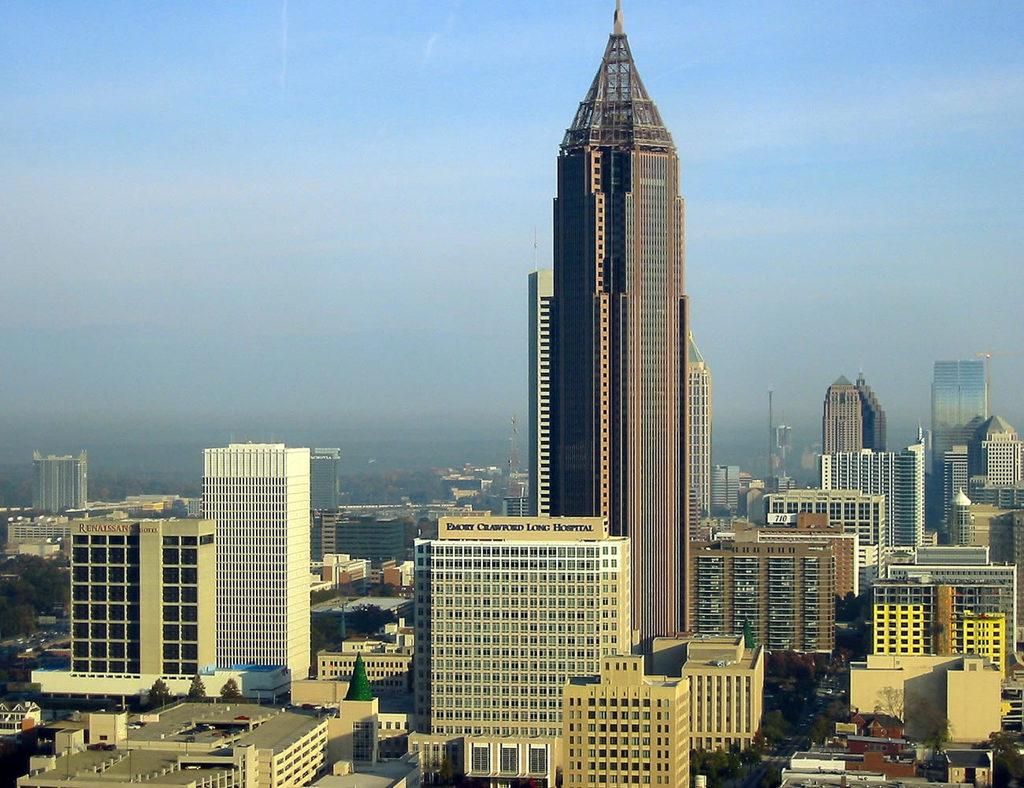What structures are located at the bottom of the image? There are buildings and skyscrapers at the bottom of the image. What else can be seen at the bottom of the image? There are trees at the bottom of the image. What type of natural feature is visible in the background of the image? There are mountains in the background of the image. What is visible at the top of the image? The sky is visible at the top of the image. What type of learning is taking place in the image? There is no indication of learning or any educational activity in the image. Can you see a cap on anyone's head in the image? There are no people or caps visible in the image. 